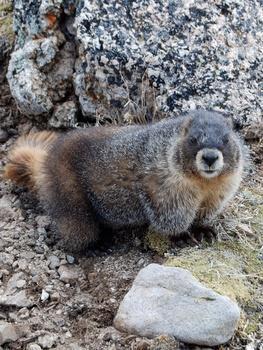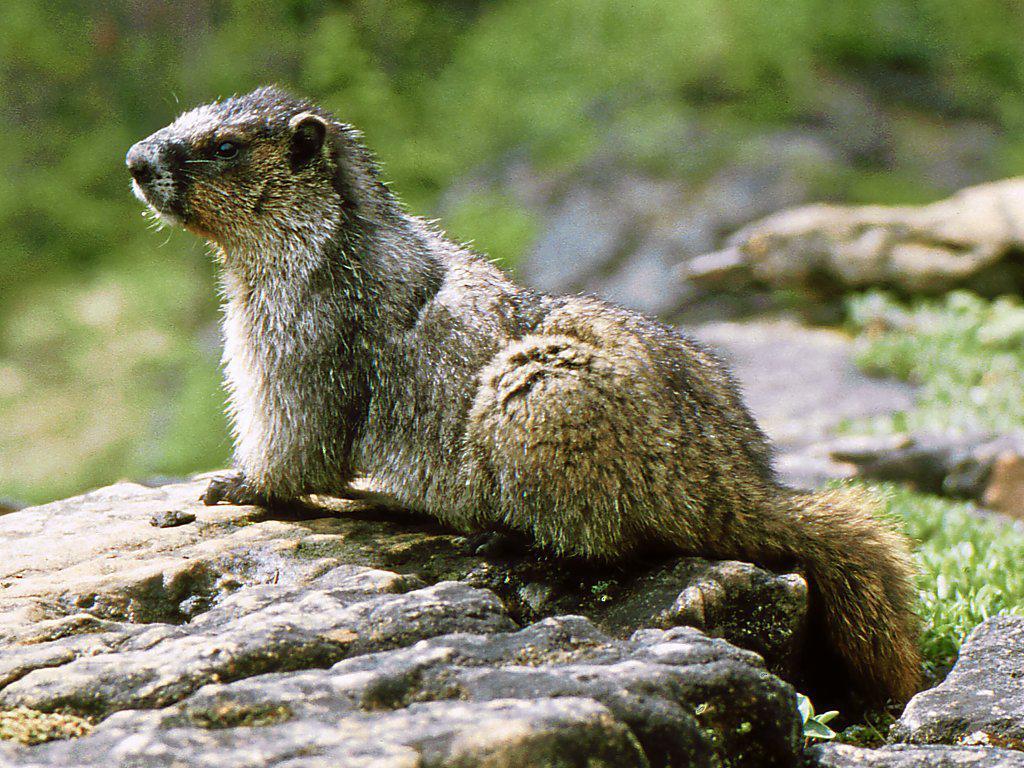The first image is the image on the left, the second image is the image on the right. Considering the images on both sides, is "At least two animals are on a rocky surface." valid? Answer yes or no. Yes. 